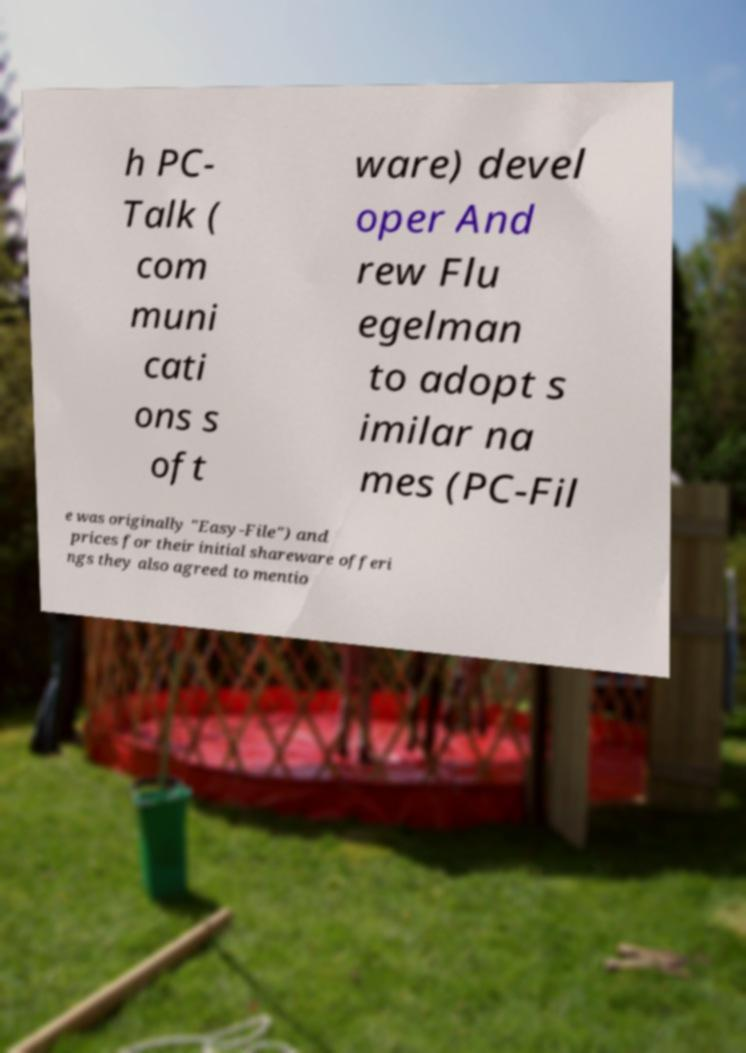Could you extract and type out the text from this image? h PC- Talk ( com muni cati ons s oft ware) devel oper And rew Flu egelman to adopt s imilar na mes (PC-Fil e was originally "Easy-File") and prices for their initial shareware offeri ngs they also agreed to mentio 